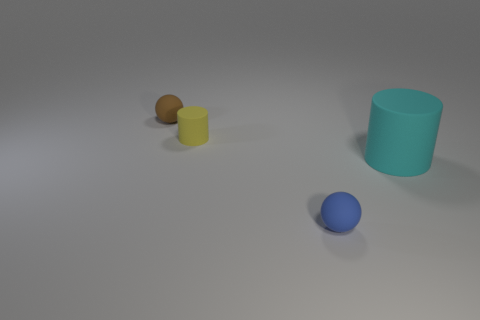Subtract all blue cylinders. Subtract all yellow spheres. How many cylinders are left? 2 Add 3 green cylinders. How many objects exist? 7 Add 2 small rubber objects. How many small rubber objects exist? 5 Subtract 0 purple blocks. How many objects are left? 4 Subtract all big red matte cubes. Subtract all tiny objects. How many objects are left? 1 Add 3 small brown things. How many small brown things are left? 4 